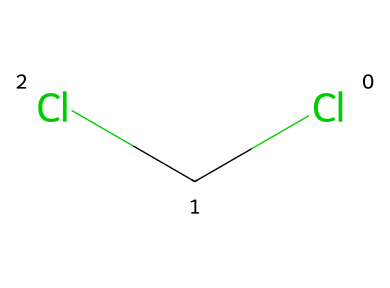What is the name of this chemical? The chemical represented by the SMILES notation ClCCl is commonly known as dichloromethane or methylene chloride.
Answer: dichloromethane How many chlorine atoms are present? Analyzing the SMILES notation ClCCl shows that there are two chlorine atoms attached to a single carbon atom.
Answer: two What type of isomerism can this compound exhibit? Given the presence of two identical groups (chlorine) and one carbon center, this compound can exhibit geometric isomerism. However, because it's symmetrical, it won't have different geometric isomers like cis and trans.
Answer: geometric isomerism Does this chemical have a symmetrical structure? The SMILES notation indicates that the chlorine atoms are on opposite sides of the carbon atom, resulting in a symmetrical structure.
Answer: yes What is the hybridization of the carbon atom in this compound? The carbon atom in dichloromethane (ClCCl) is bonded to two chlorine atoms and has two remaining hydrogen atoms, indicating it is sp3 hybridized.
Answer: sp3 What types of intermolecular forces does this compound exhibit? The presence of polar C-Cl bonds suggests that dichloromethane exhibits dipole-dipole interactions as its primary intermolecular force along with some dispersion forces.
Answer: dipole-dipole What is the molecular formula for this chemical? By combining the components from the SMILES notation, there is one carbon (C), two chlorines (Cl), and two hydrogens (H) giving the molecular formula C2H2Cl2.
Answer: C2H2Cl2 